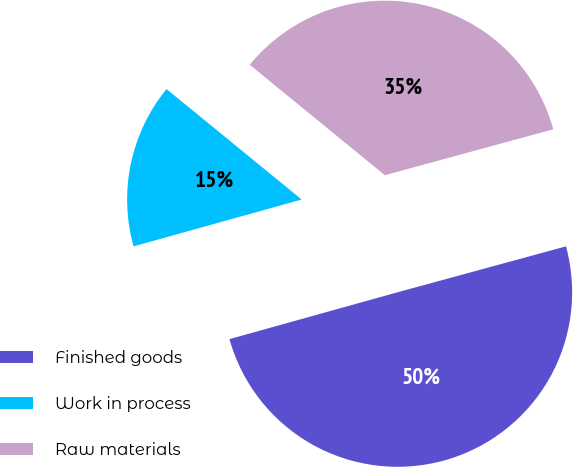Convert chart to OTSL. <chart><loc_0><loc_0><loc_500><loc_500><pie_chart><fcel>Finished goods<fcel>Work in process<fcel>Raw materials<nl><fcel>49.91%<fcel>15.23%<fcel>34.86%<nl></chart> 